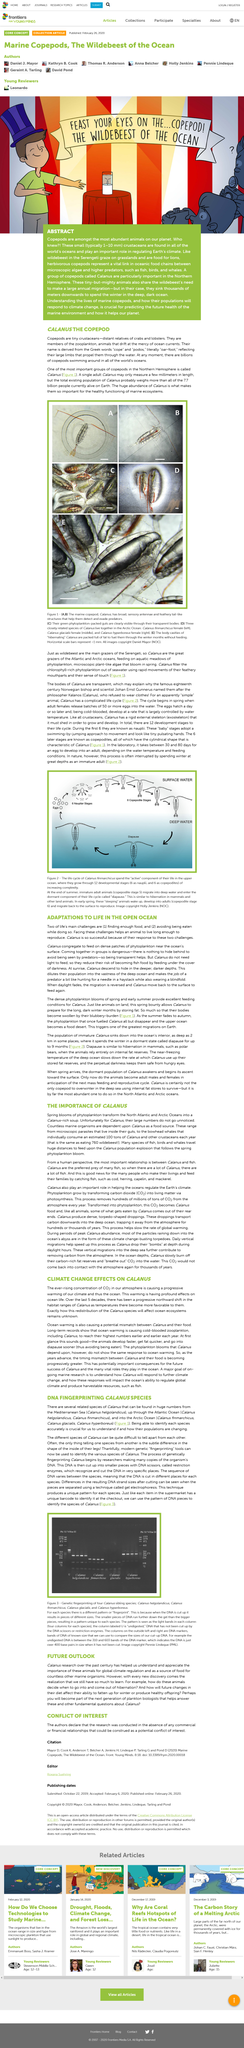Give some essential details in this illustration. The ever-increasing concentration of CO2 in our atmosphere is leading to progressive warming of our climate, which in turn is affecting the ocean. Coelenterates in the ocean serve as food sources for various animals such as fish, birds, and whales. The photo depicts the life cycle of the Calanus, which is a type of krill. The most abundant animal on our planet is copepods, which make up a significant portion of the ocean's biomass. The consumption of Calanus by a single bowhead whale is estimated to be approximately 100 tons per year. 